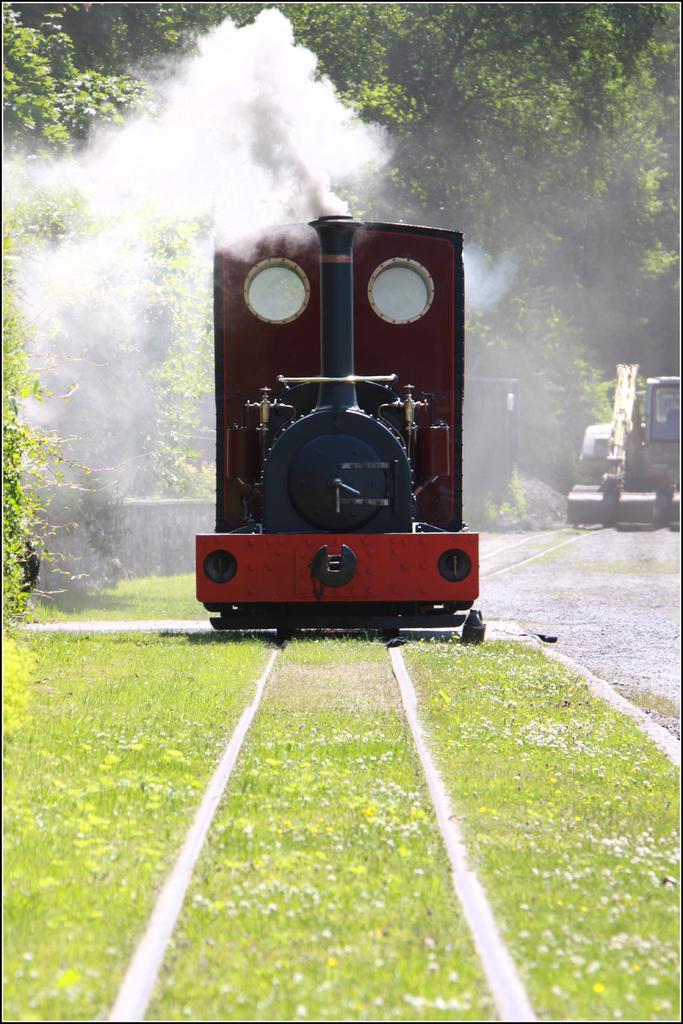Can you describe this image briefly? In this image there is a train, there is grass, there are treeś, there is a road, towardś the right of the image there is a vehicle. 